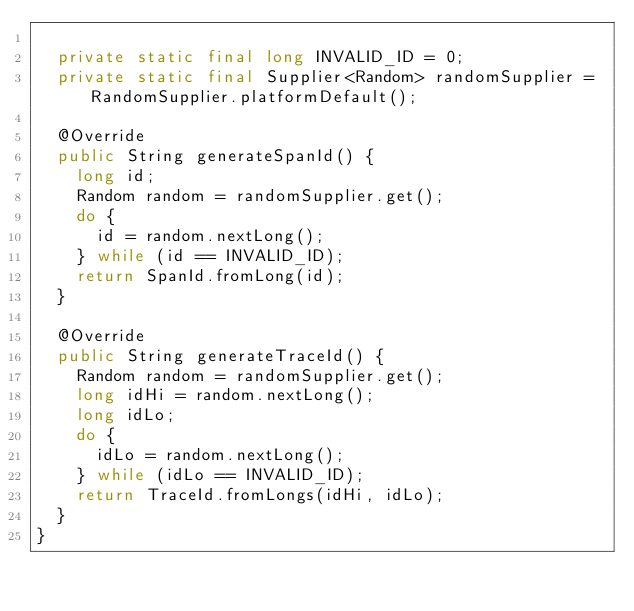<code> <loc_0><loc_0><loc_500><loc_500><_Java_>
  private static final long INVALID_ID = 0;
  private static final Supplier<Random> randomSupplier = RandomSupplier.platformDefault();

  @Override
  public String generateSpanId() {
    long id;
    Random random = randomSupplier.get();
    do {
      id = random.nextLong();
    } while (id == INVALID_ID);
    return SpanId.fromLong(id);
  }

  @Override
  public String generateTraceId() {
    Random random = randomSupplier.get();
    long idHi = random.nextLong();
    long idLo;
    do {
      idLo = random.nextLong();
    } while (idLo == INVALID_ID);
    return TraceId.fromLongs(idHi, idLo);
  }
}
</code> 